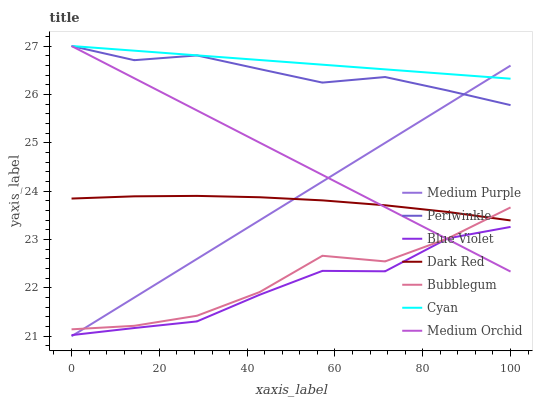Does Medium Orchid have the minimum area under the curve?
Answer yes or no. No. Does Medium Orchid have the maximum area under the curve?
Answer yes or no. No. Is Medium Orchid the smoothest?
Answer yes or no. No. Is Medium Orchid the roughest?
Answer yes or no. No. Does Medium Orchid have the lowest value?
Answer yes or no. No. Does Bubblegum have the highest value?
Answer yes or no. No. Is Dark Red less than Periwinkle?
Answer yes or no. Yes. Is Periwinkle greater than Blue Violet?
Answer yes or no. Yes. Does Dark Red intersect Periwinkle?
Answer yes or no. No. 